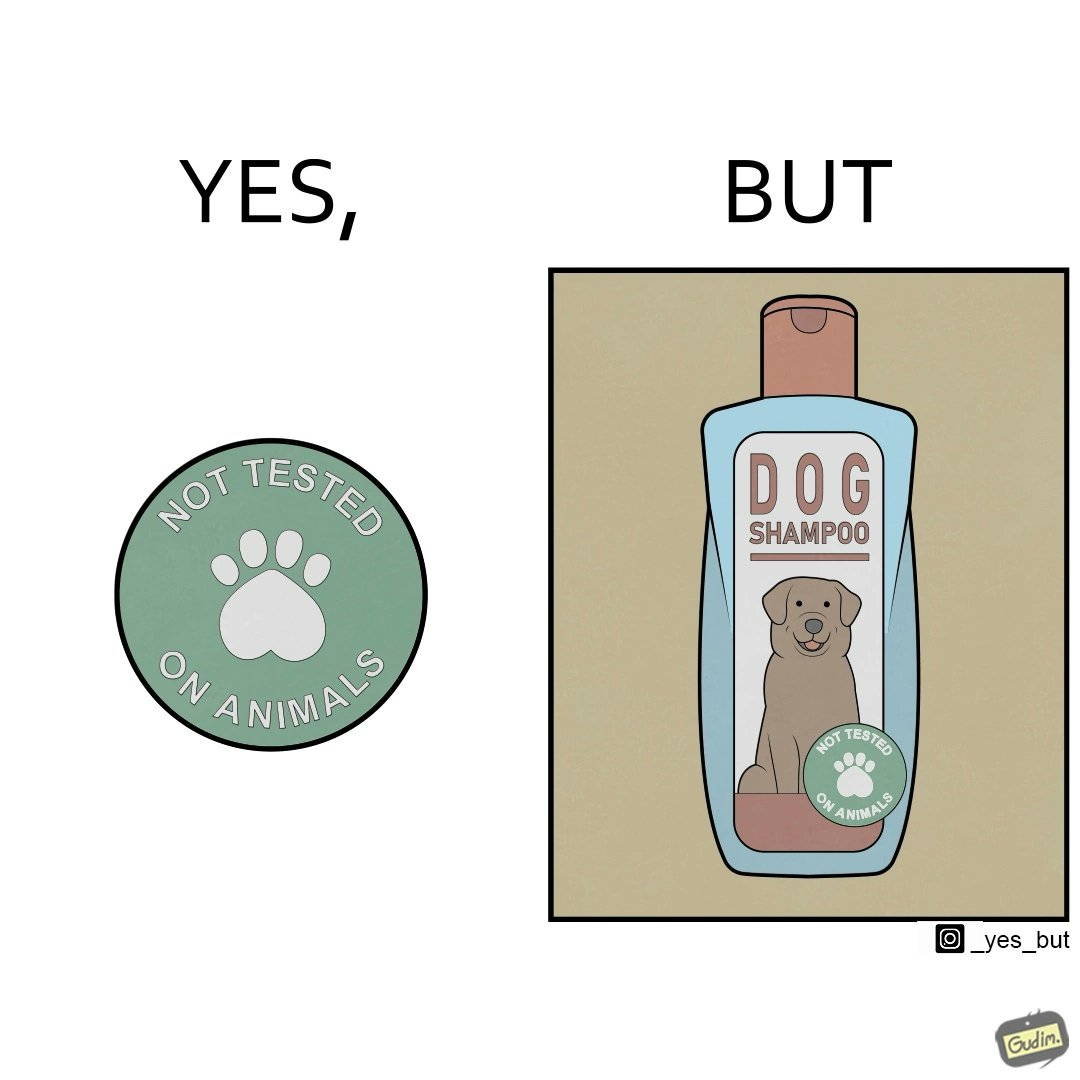Describe the contrast between the left and right parts of this image. In the left part of the image: It is a tag saying "not tested on animals" In the right part of the image: It is a dog shampoo bottle. 